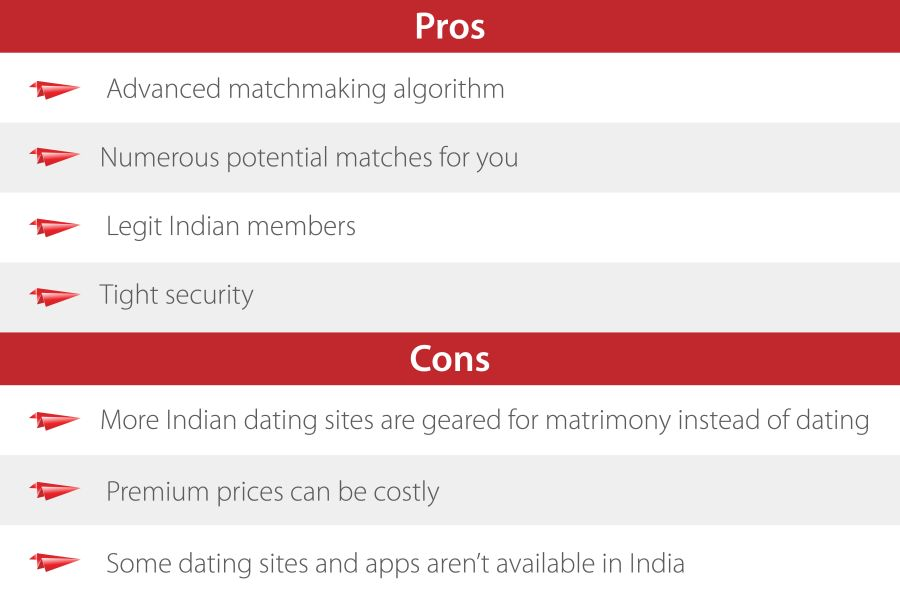Considering the context of the image, what might be the intended audience or user base for the service being described by the list of Pros and Cons? The intended audience or user base for the service being described appears to be individuals in India looking for online dating or matchmaking services. This inference is drawn from the specific mention of "Legit Indian members" in the Pros section, and the reference to Indian dating sites and the availability of apps in India in the Cons section. 